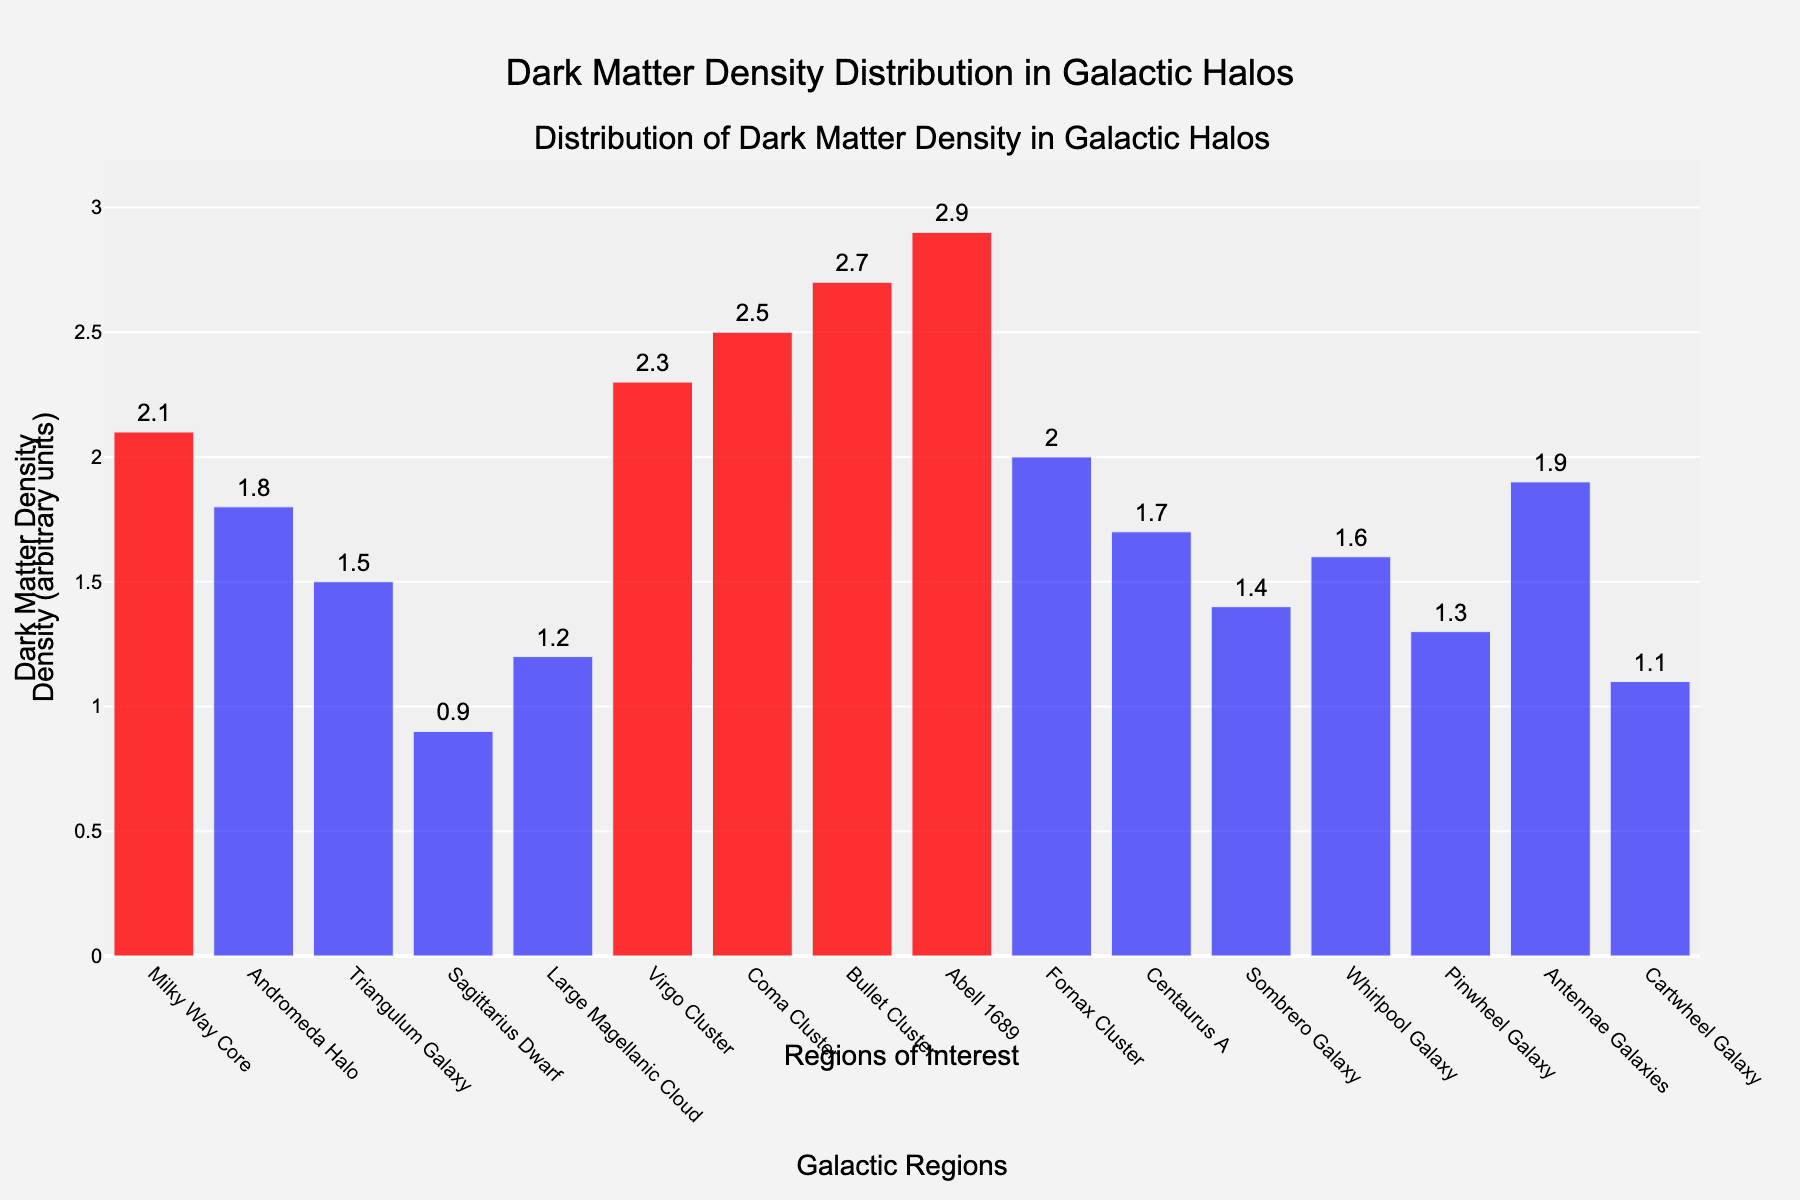What's the title of the figure? The title of the figure is displayed at the top of the plot. It reads "Dark Matter Density Distribution in Galactic Halos".
Answer: Dark Matter Density Distribution in Galactic Halos Which galactic region has the highest dark matter density? By looking at the height of the bars, the galactic region with the highest dark matter density is "Abell 1689".
Answer: Abell 1689 What is the dark matter density of the Milky Way Core? The height of the bar corresponding to the "Milky Way Core" indicates a dark matter density of 2.1.
Answer: 2.1 How many galactic regions have a dark matter density greater than 2? The bars highlighted in red represent densities greater than 2. These regions are Milky Way Core, Virgo Cluster, Coma Cluster, Bullet Cluster, and Abell 1689. Counting these gives 5 regions.
Answer: 5 What is the average dark matter density of the regions with densities less than 2? First, identify regions with densities less than 2: Andromeda Halo (1.8), Triangulum Galaxy (1.5), Sagittarius Dwarf (0.9), Large Magellanic Cloud (1.2), Centaurus A (1.7), Sombrero Galaxy (1.4), Whirlpool Galaxy (1.6), Pinwheel Galaxy (1.3), Antennae Galaxies (1.9), Cartwheel Galaxy (1.1). Sum these densities: 13.4, then divide by number of regions (10).
Answer: 1.34 Which galactic region has the lowest dark matter density? By examining the height of all the bars in the figure, "Sagittarius Dwarf" has the lowest dark matter density.
Answer: Sagittarius Dwarf What's the difference in dark matter density between the Virgo Cluster and the Bullet Cluster? Look at the heights of the bars representing the Virgo Cluster (2.3) and the Bullet Cluster (2.7). The difference is 2.7 - 2.3 = 0.4.
Answer: 0.4 How many galactic regions are represented in the plot? Count the number of bars in the plot or refer to the names listed on the x-axis. There are 16 regions in total.
Answer: 16 Which has a higher dark matter density, the Andromeda Halo or the Sombrero Galaxy? Compare the heights of the bars for "Andromeda Halo" (1.8) and "Sombrero Galaxy" (1.4). The Andromeda Halo has a higher density.
Answer: Andromeda Halo 